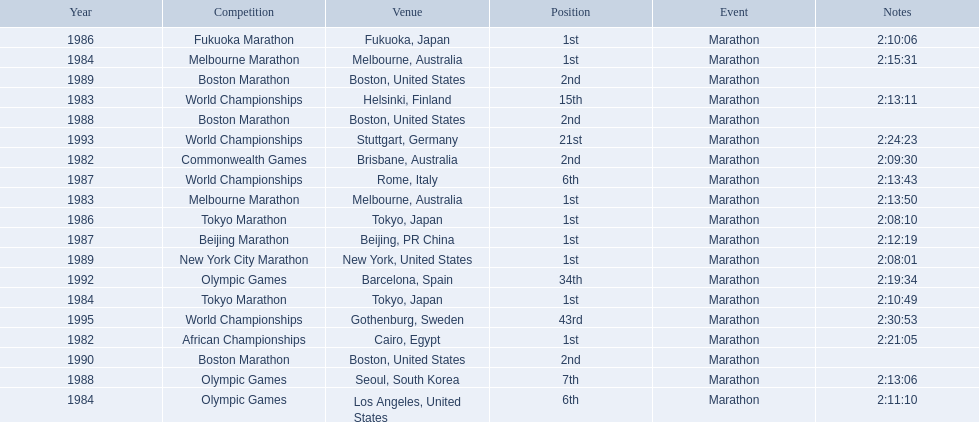What are the competitions? African Championships, Cairo, Egypt, Commonwealth Games, Brisbane, Australia, World Championships, Helsinki, Finland, Melbourne Marathon, Melbourne, Australia, Tokyo Marathon, Tokyo, Japan, Olympic Games, Los Angeles, United States, Melbourne Marathon, Melbourne, Australia, Tokyo Marathon, Tokyo, Japan, Fukuoka Marathon, Fukuoka, Japan, World Championships, Rome, Italy, Beijing Marathon, Beijing, PR China, Olympic Games, Seoul, South Korea, Boston Marathon, Boston, United States, New York City Marathon, New York, United States, Boston Marathon, Boston, United States, Boston Marathon, Boston, United States, Olympic Games, Barcelona, Spain, World Championships, Stuttgart, Germany, World Championships, Gothenburg, Sweden. Which ones occured in china? Beijing Marathon, Beijing, PR China. Which one is it? Beijing Marathon. 